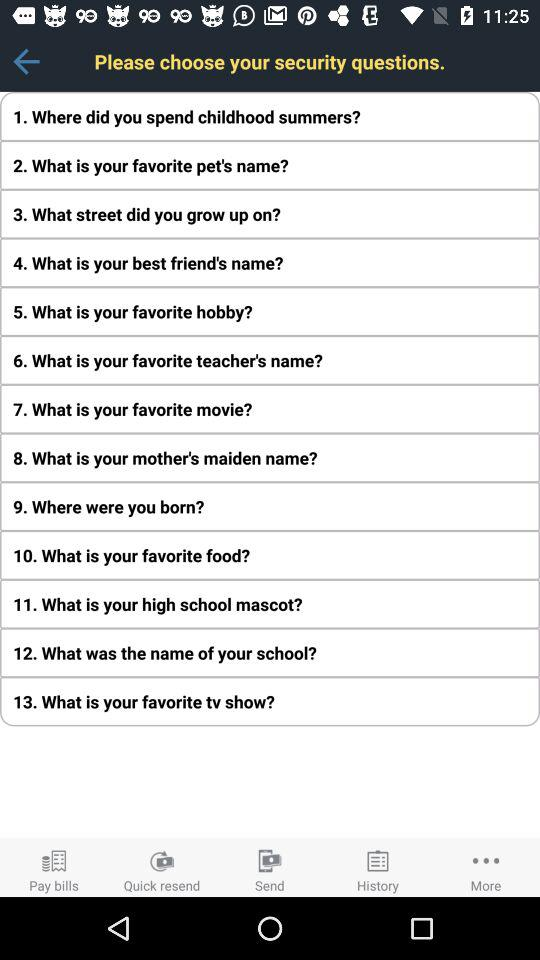How many security questions are there?
Answer the question using a single word or phrase. 13 